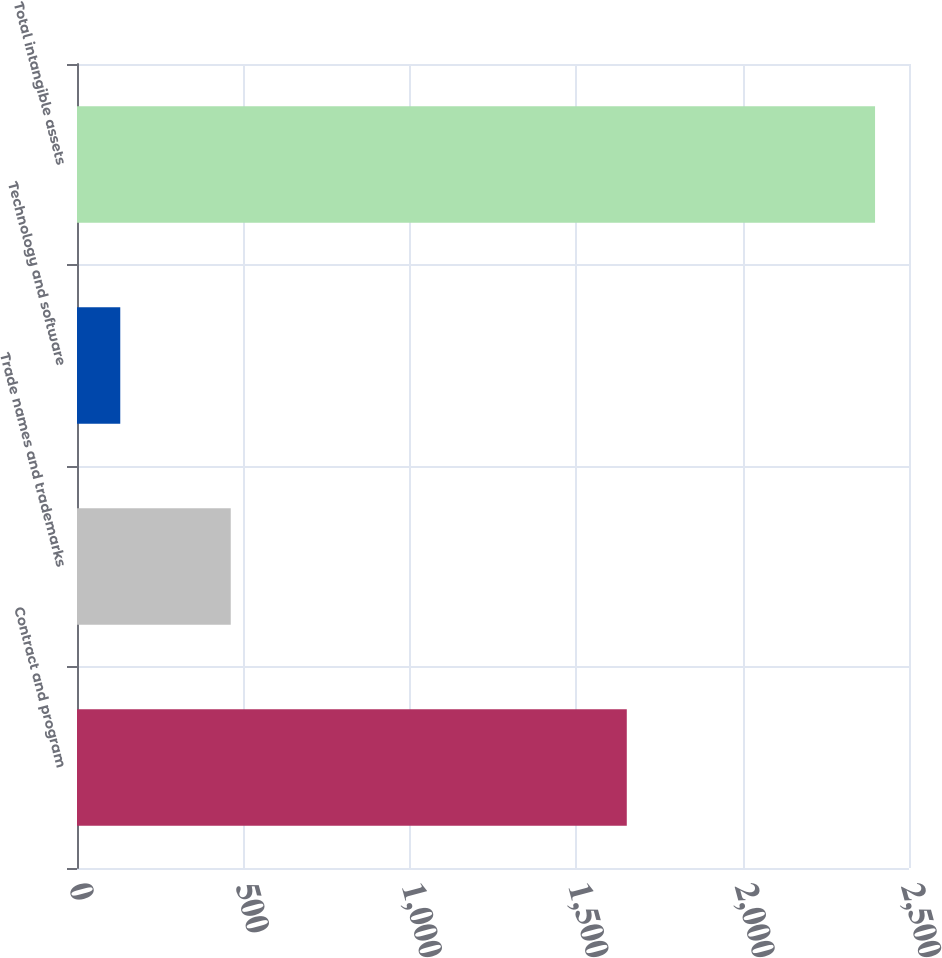Convert chart. <chart><loc_0><loc_0><loc_500><loc_500><bar_chart><fcel>Contract and program<fcel>Trade names and trademarks<fcel>Technology and software<fcel>Total intangible assets<nl><fcel>1652<fcel>462<fcel>130<fcel>2398<nl></chart> 